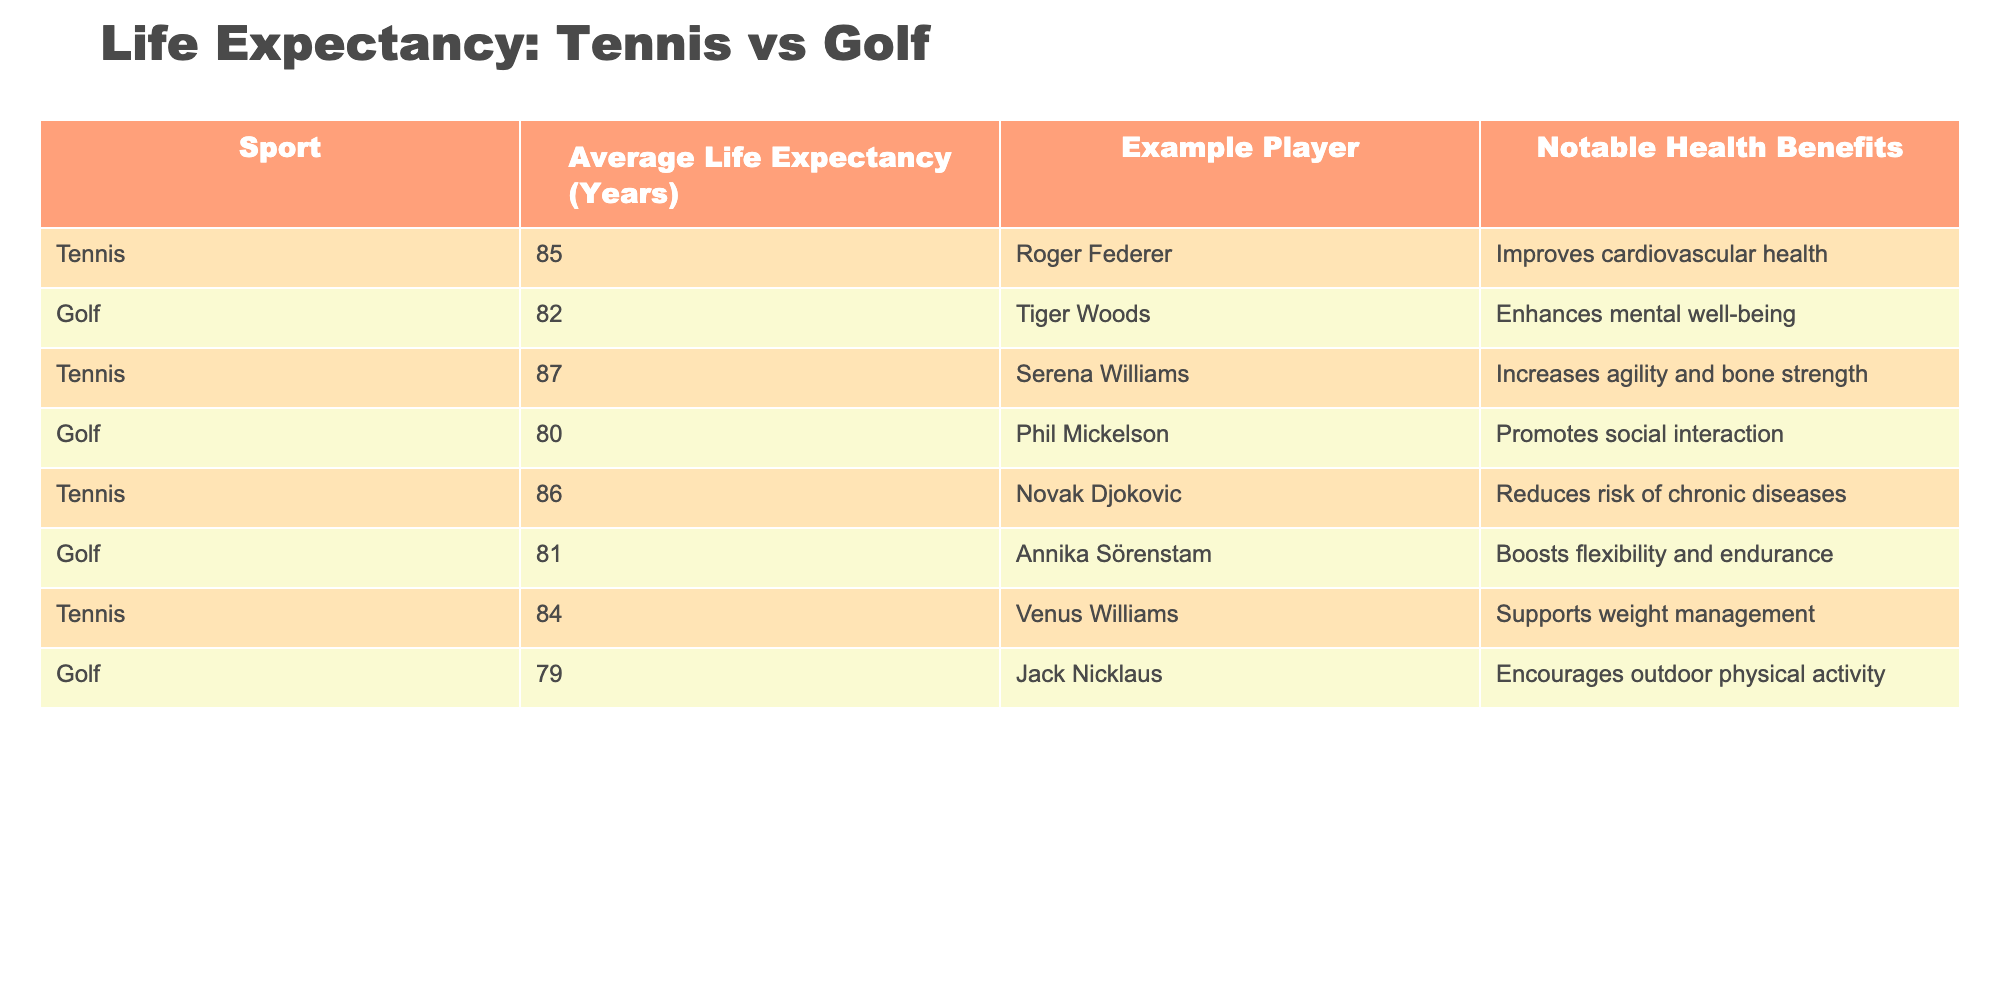What is the average life expectancy for tennis players listed in the table? The table provides life expectancy values for tennis players: 85, 87, 86, 84. To find the average, sum these values: 85 + 87 + 86 + 84 = 342. Then, divide by the number of players (4): 342 / 4 = 85.5.
Answer: 85.5 What is the life expectancy of the oldest golfer in the table? The table presents the life expectancies for golfers: 82, 80, 81, 79. The highest value is 82 for Tiger Woods, indicating he has the longest life expectancy among golfers listed.
Answer: 82 Is it true that tennis players have a higher average life expectancy than golfers in the table? The average life expectancy for tennis players is 85.5 and for golfers is calculated as: (82 + 80 + 81 + 79) / 4 = 80.5. Since 85.5 > 80.5, it is true that tennis players have a higher average life expectancy.
Answer: Yes What is the difference in average life expectancy between tennis players and golfers? We first find the average for golfers: (82 + 80 + 81 + 79) / 4 = 80.5. We already calculated the tennis players' average as 85.5. The difference is 85.5 - 80.5 = 5.
Answer: 5 Which sport has a player with the highest life expectancy, and what is that expectancy? By examining the table, the highest life expectancy is 87 for Serena Williams, a tennis player. No golfer reaches this high value.
Answer: Tennis with an expectancy of 87 What notable health benefit is shared by both tennis players and golfers according to the table? Tennis players improve cardiovascular health, while golfers enhance mental well-being. Neither health benefit shares a common aspect directly mentioned; hence, there is no shared benefit.
Answer: No shared benefit What is the average life expectancy for all individuals mentioned in the table? First, add all life expectancies: 85 + 87 + 86 + 84 + 82 + 80 + 81 + 79 =  694. Then divide by the number of individuals, which is 8: 694 / 8 = 86.75.
Answer: 86.75 Which tennis player has an expectancy lower than any golfer listed? The lowest life expectancy for golfers is 79 for Jack Nicklaus, while the lowest for tennis players listed is 84 for Venus Williams. Therefore, no tennis player has a lower expectancy.
Answer: No How many tennis players are there with an expectancy above 85 years? The tennis players listed with expectancies above 85 are: 87 (Serena Williams), 86 (Novak Djokovic), and 85 (Roger Federer). Therefore, there are 3 players.
Answer: 3 